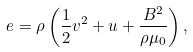Convert formula to latex. <formula><loc_0><loc_0><loc_500><loc_500>e = \rho \left ( \frac { 1 } { 2 } v ^ { 2 } + u + \frac { B ^ { 2 } } { \rho \mu _ { 0 } } \right ) ,</formula> 